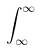Convert formula to latex. <formula><loc_0><loc_0><loc_500><loc_500>\int _ { \infty } ^ { \infty }</formula> 